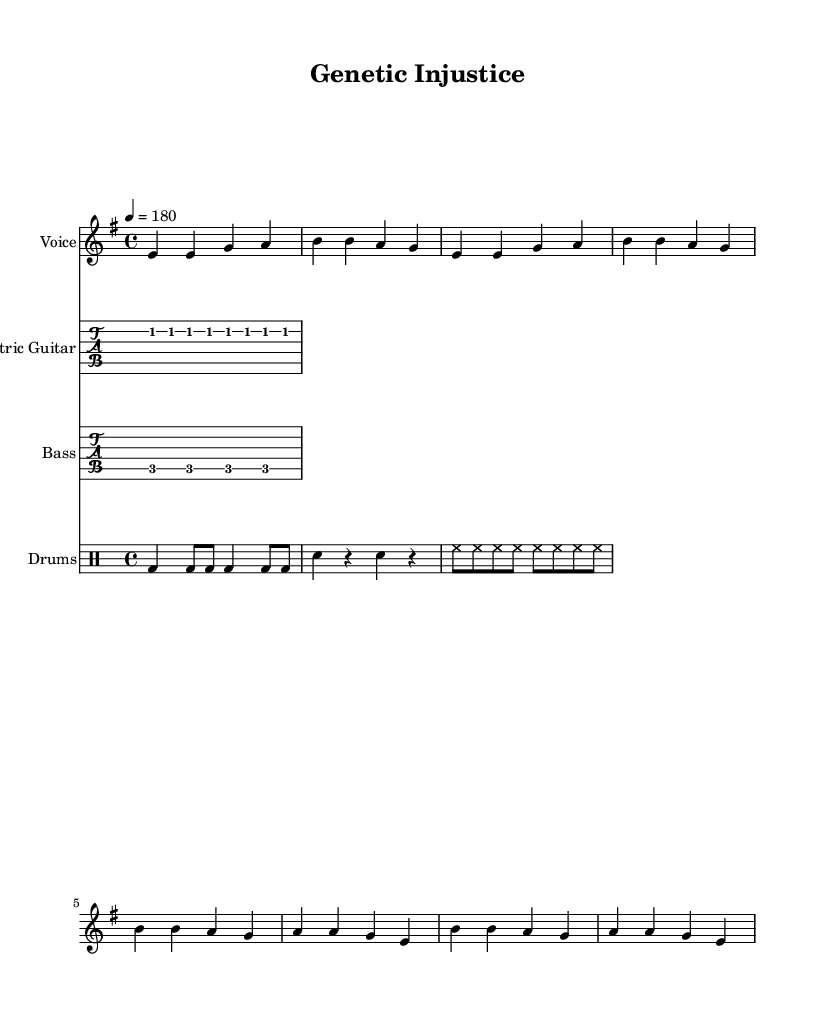What is the key signature of this music? The key signature is indicated as E minor, which is represented by one sharp (F#) in the notation. E minor is the relative minor of G major.
Answer: E minor What is the time signature of the music? The time signature is displayed as 4/4, which means there are four beats per measure, and the quarter note gets one beat. This is a common time signature in punk music.
Answer: 4/4 What is the tempo marking for this piece? The tempo is specified as 180 beats per minute, which is indicated by the notation '4 = 180'. This signifies a fast-paced, energetic feel typical of punk music.
Answer: 180 What is the main theme of the lyrics in this song? The lyrics revolve around "genetic injustice" and the demand for a cure concerning ovarian cancer, suggesting a critique of the health care system's response to cancer treatment.
Answer: Genetic injustice How many measures are in the verse of the melody? Upon reviewing the verse section given, there are eight measures are presented before it transitions into the chorus. Since the verse repetitions are counted, they are concluded as a single section.
Answer: 8 What instruments are included in this composition? The score includes the following instruments: Voice for the melody, Electric Guitar, Bass, and Drums. Each one is assigned a staff in the sheet music layout for performance.
Answer: Voice, Electric Guitar, Bass, Drums What is the significance of the lyrics in connection to ovarian cancer? The lyrics highlight the urgency of addressing genetics in cancer treatment and reflect a protest against insufficient healthcare responses, drawing a direct line to ovarian cancer patients' experiences.
Answer: Demand for cure 